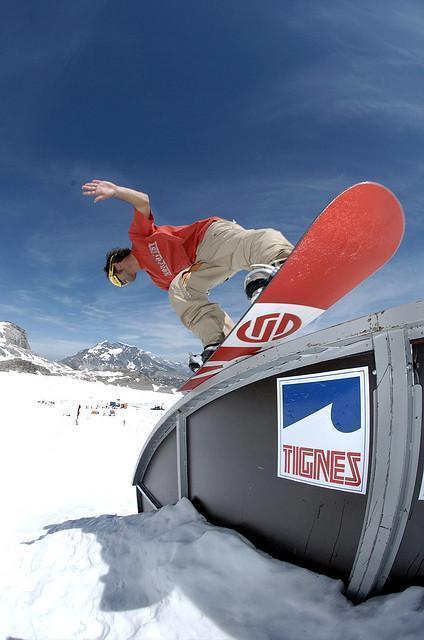What is this type of snowboard trick called?
Choose the right answer from the provided options to respond to the question.
Options: Grinding, nollie, 360 flip, ollie. Grinding. 